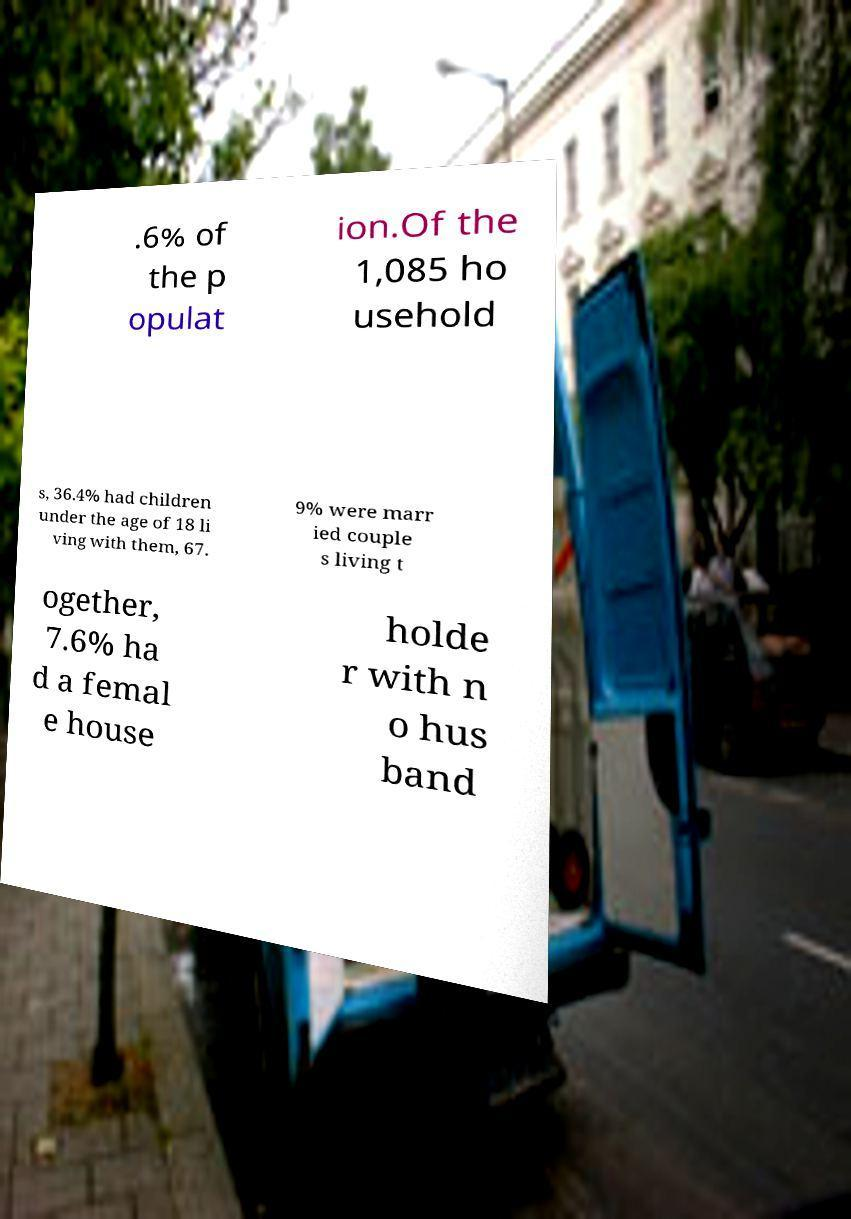Could you extract and type out the text from this image? .6% of the p opulat ion.Of the 1,085 ho usehold s, 36.4% had children under the age of 18 li ving with them, 67. 9% were marr ied couple s living t ogether, 7.6% ha d a femal e house holde r with n o hus band 